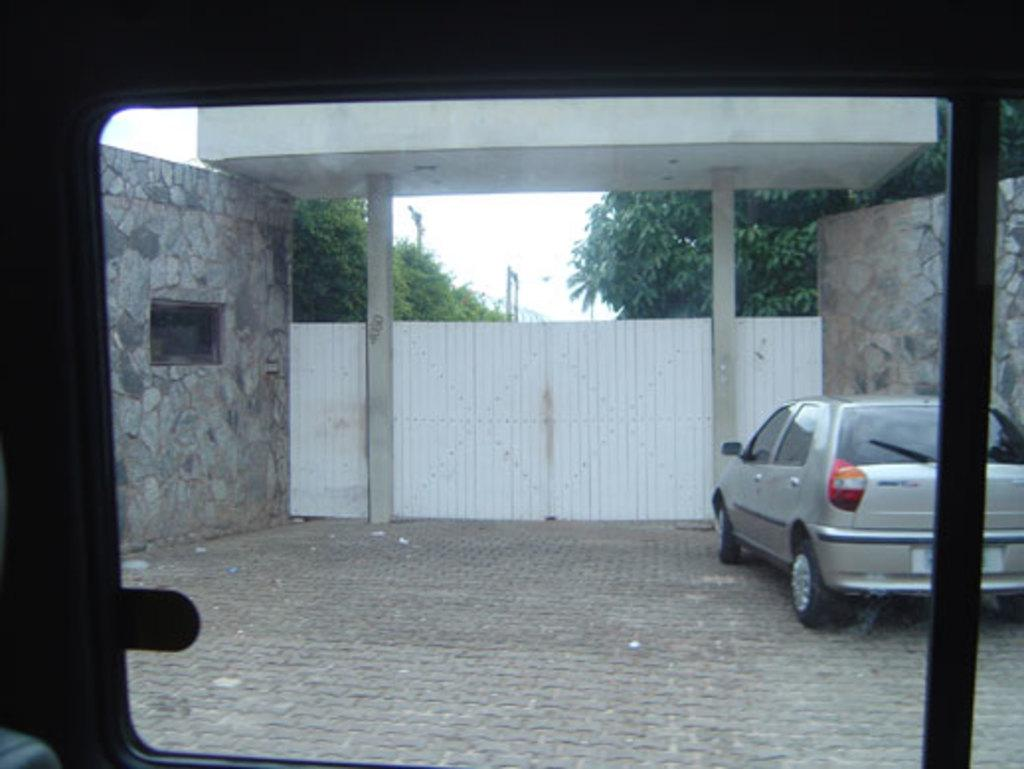What type of motor vehicle is on the floor in the image? The facts do not specify the type of motor vehicle, only that there is one on the floor. What can be seen in the image besides the motor vehicle? There is a gate, trees, walls, and the sky visible in the image. Can you describe the gate in the image? The facts do not provide specific details about the gate, only that it is present in the image. What is the color of the sky in the image? The facts do not mention the color of the sky, only that it is visible in the image. How many feathers can be seen on the motor vehicle in the image? There are no feathers present on the motor vehicle in the image. 